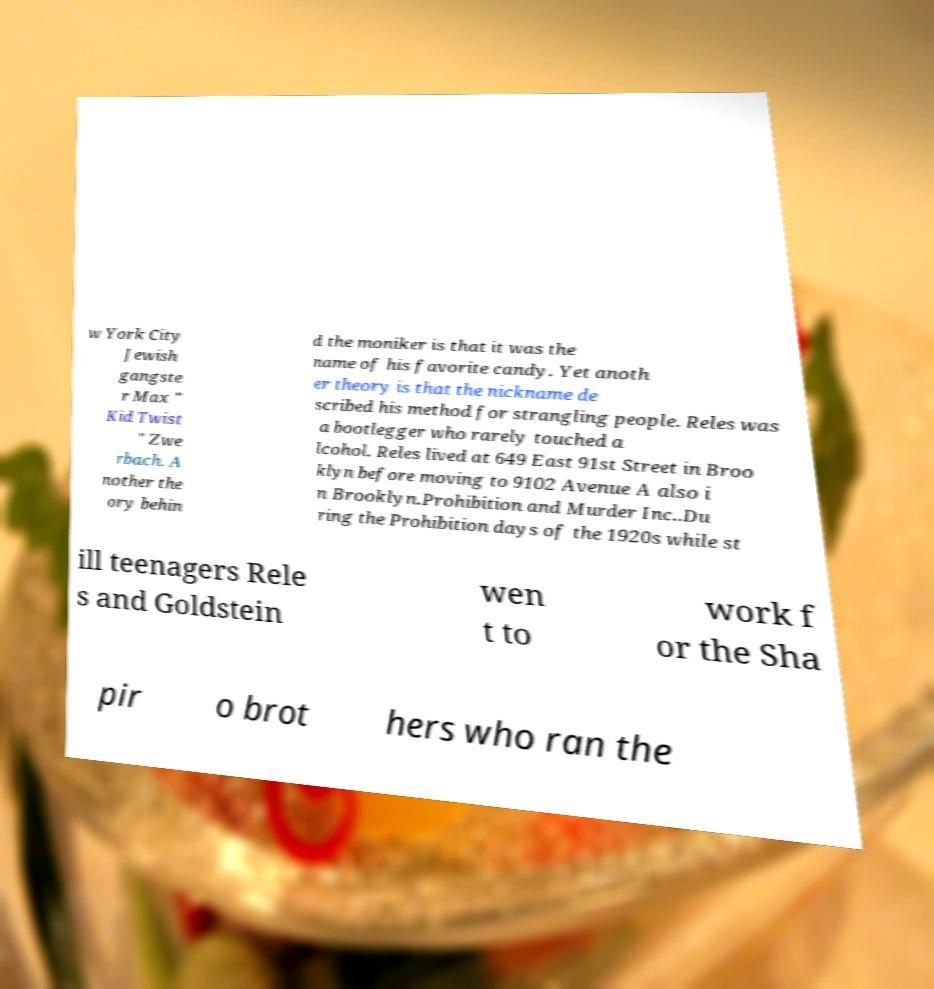Could you assist in decoding the text presented in this image and type it out clearly? w York City Jewish gangste r Max " Kid Twist " Zwe rbach. A nother the ory behin d the moniker is that it was the name of his favorite candy. Yet anoth er theory is that the nickname de scribed his method for strangling people. Reles was a bootlegger who rarely touched a lcohol. Reles lived at 649 East 91st Street in Broo klyn before moving to 9102 Avenue A also i n Brooklyn.Prohibition and Murder Inc..Du ring the Prohibition days of the 1920s while st ill teenagers Rele s and Goldstein wen t to work f or the Sha pir o brot hers who ran the 